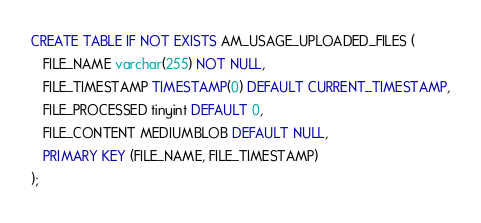Convert code to text. <code><loc_0><loc_0><loc_500><loc_500><_SQL_>
CREATE TABLE IF NOT EXISTS AM_USAGE_UPLOADED_FILES (
   FILE_NAME varchar(255) NOT NULL,
   FILE_TIMESTAMP TIMESTAMP(0) DEFAULT CURRENT_TIMESTAMP,
   FILE_PROCESSED tinyint DEFAULT 0,
   FILE_CONTENT MEDIUMBLOB DEFAULT NULL,
   PRIMARY KEY (FILE_NAME, FILE_TIMESTAMP)
);</code> 